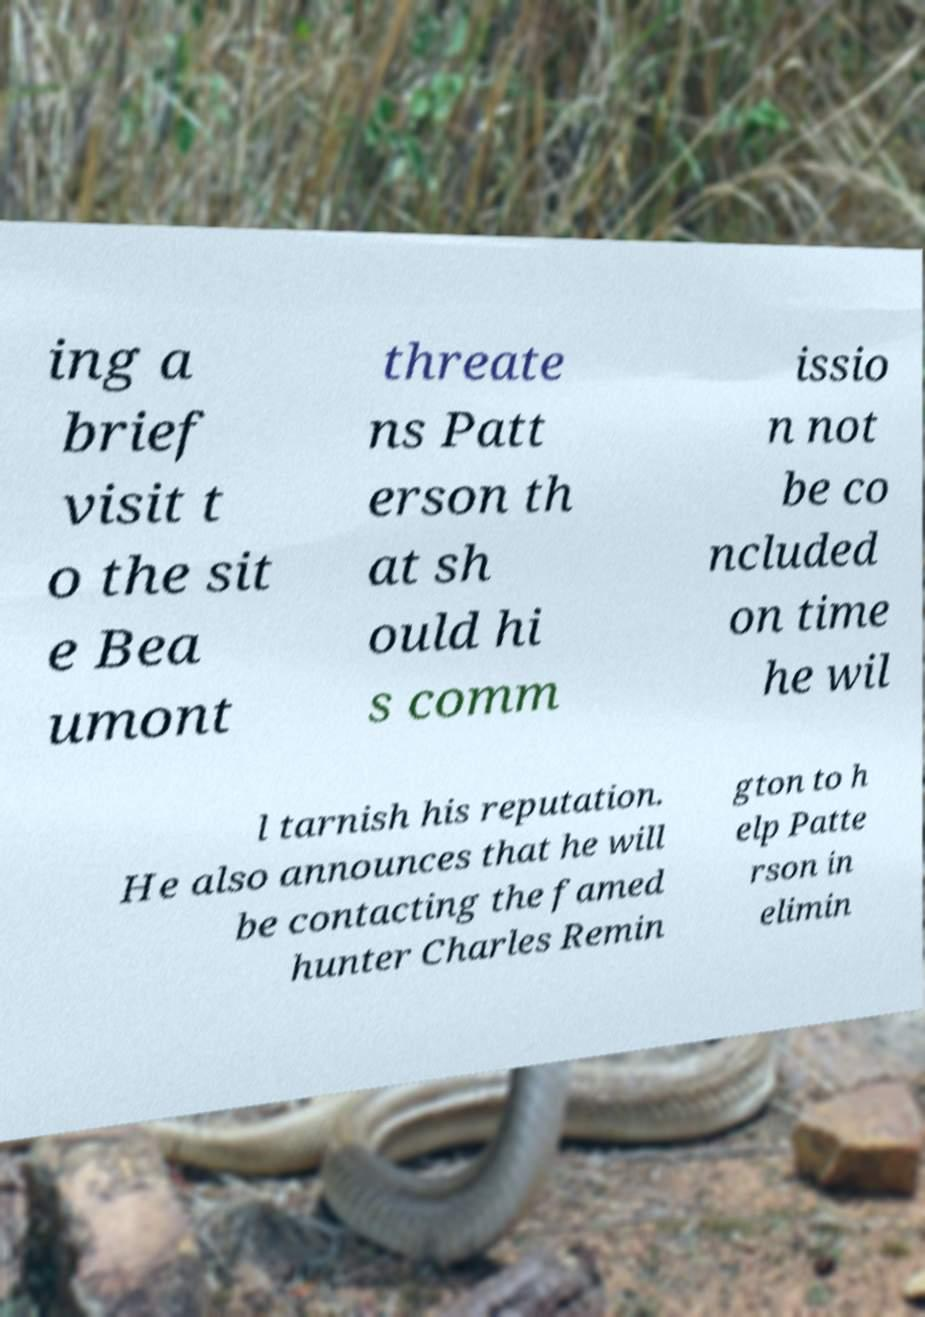I need the written content from this picture converted into text. Can you do that? ing a brief visit t o the sit e Bea umont threate ns Patt erson th at sh ould hi s comm issio n not be co ncluded on time he wil l tarnish his reputation. He also announces that he will be contacting the famed hunter Charles Remin gton to h elp Patte rson in elimin 